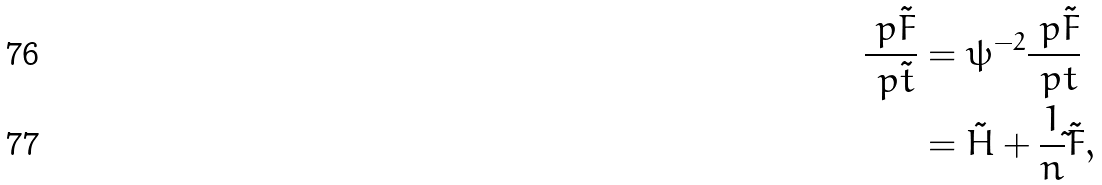Convert formula to latex. <formula><loc_0><loc_0><loc_500><loc_500>\frac { \ p \tilde { F } } { \ p \tilde { t } } & = \psi ^ { - 2 } \frac { \ p \tilde { F } } { \ p t } \\ & = \tilde { H } + \frac { 1 } { n } \tilde { } \tilde { F } ,</formula> 